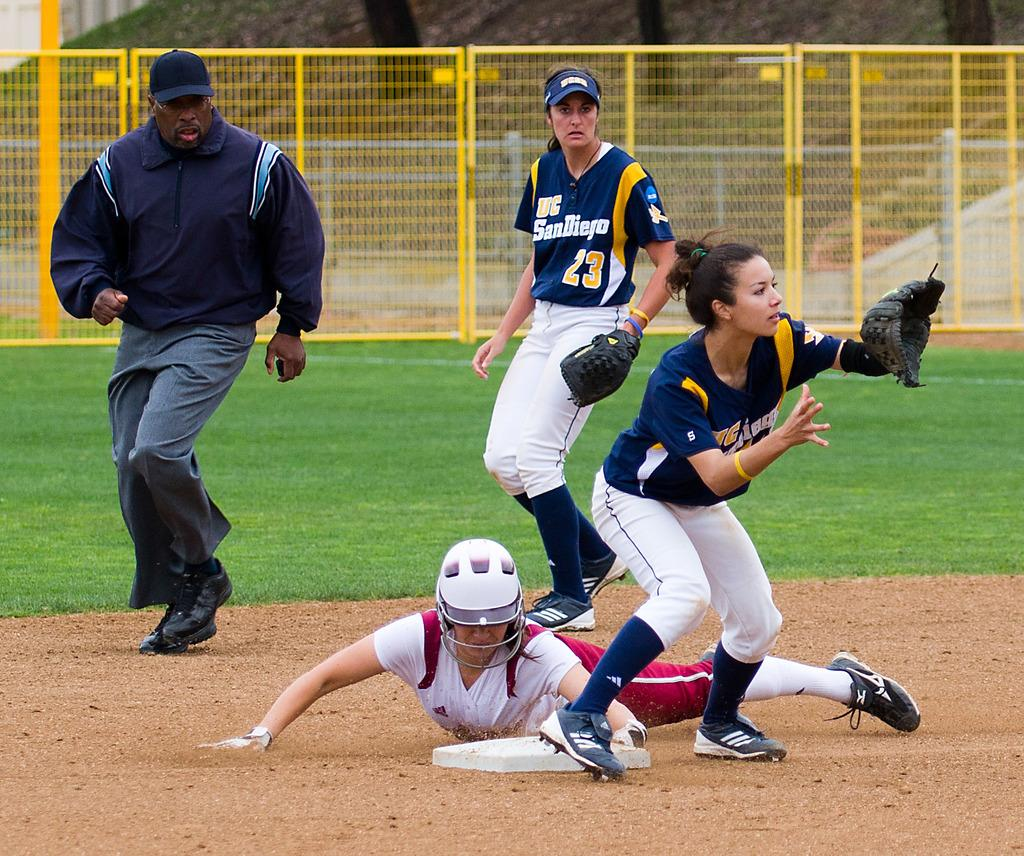Provide a one-sentence caption for the provided image. A UC San Diego ball player is poised to make a catch. 